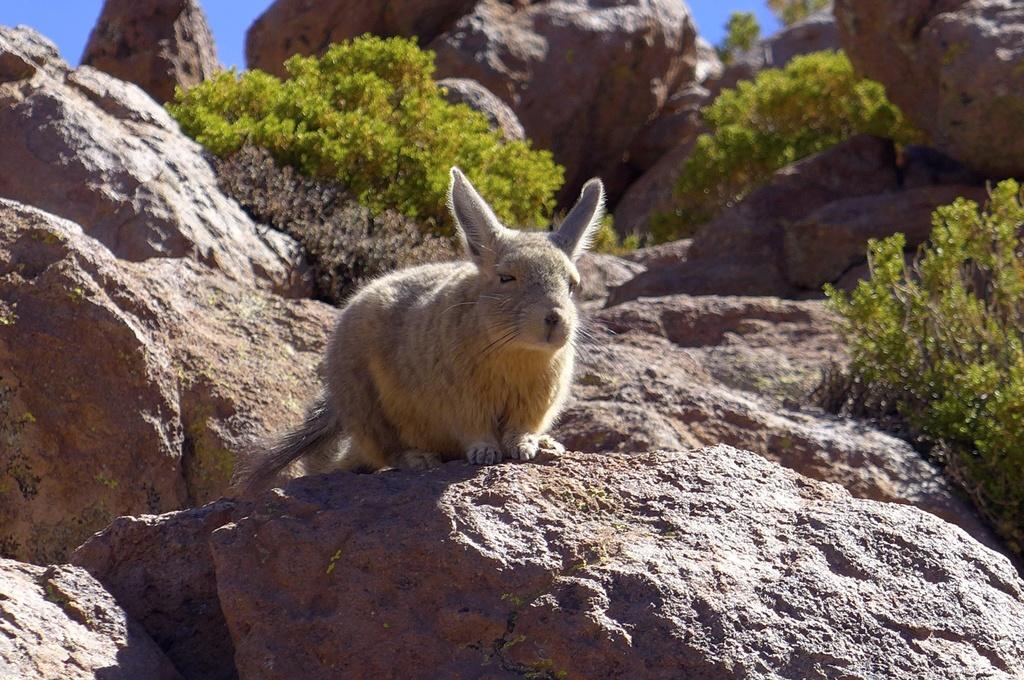Can you describe this image briefly? In this picture we can see a rabbit in the front, in the background there are some rocks and plants, we can see the sky at the left top of the picture. 